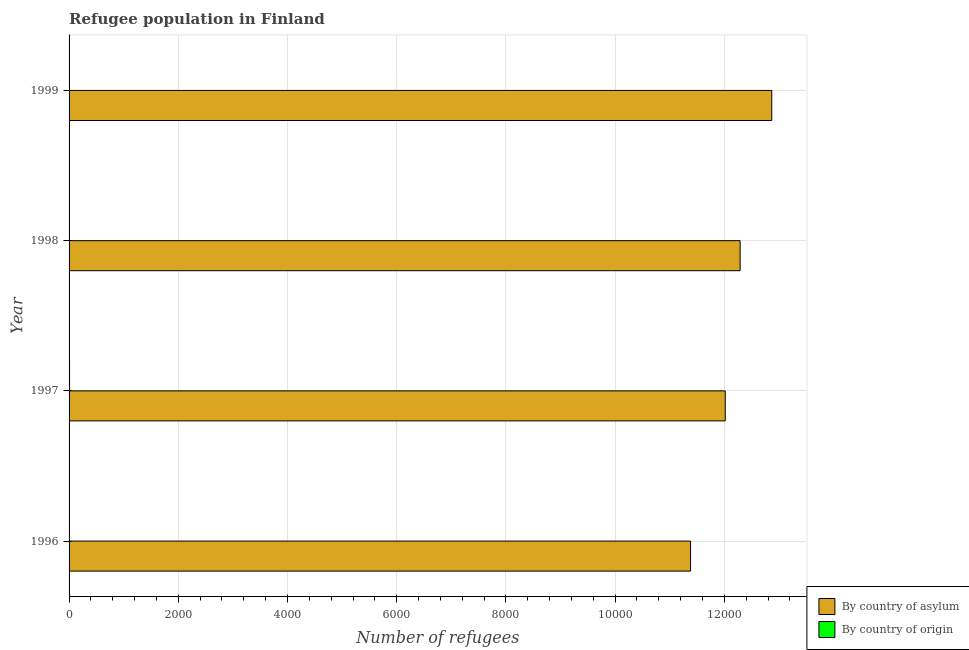Are the number of bars on each tick of the Y-axis equal?
Offer a terse response. Yes. How many bars are there on the 3rd tick from the top?
Provide a short and direct response. 2. How many bars are there on the 2nd tick from the bottom?
Give a very brief answer. 2. What is the label of the 3rd group of bars from the top?
Keep it short and to the point. 1997. In how many cases, is the number of bars for a given year not equal to the number of legend labels?
Keep it short and to the point. 0. What is the number of refugees by country of asylum in 1998?
Your response must be concise. 1.23e+04. Across all years, what is the maximum number of refugees by country of origin?
Your answer should be compact. 9. Across all years, what is the minimum number of refugees by country of origin?
Your answer should be very brief. 2. In which year was the number of refugees by country of origin maximum?
Make the answer very short. 1997. What is the total number of refugees by country of asylum in the graph?
Make the answer very short. 4.86e+04. What is the difference between the number of refugees by country of asylum in 1996 and that in 1999?
Your answer should be very brief. -1487. What is the difference between the number of refugees by country of origin in 1999 and the number of refugees by country of asylum in 1996?
Your response must be concise. -1.14e+04. What is the average number of refugees by country of asylum per year?
Ensure brevity in your answer.  1.21e+04. In the year 1997, what is the difference between the number of refugees by country of asylum and number of refugees by country of origin?
Your answer should be very brief. 1.20e+04. What is the ratio of the number of refugees by country of asylum in 1998 to that in 1999?
Offer a terse response. 0.95. Is the number of refugees by country of origin in 1997 less than that in 1999?
Your answer should be very brief. No. Is the difference between the number of refugees by country of asylum in 1996 and 1999 greater than the difference between the number of refugees by country of origin in 1996 and 1999?
Make the answer very short. No. What is the difference between the highest and the second highest number of refugees by country of origin?
Give a very brief answer. 2. What is the difference between the highest and the lowest number of refugees by country of asylum?
Your answer should be very brief. 1487. In how many years, is the number of refugees by country of asylum greater than the average number of refugees by country of asylum taken over all years?
Offer a terse response. 2. Is the sum of the number of refugees by country of origin in 1996 and 1999 greater than the maximum number of refugees by country of asylum across all years?
Offer a terse response. No. What does the 2nd bar from the top in 1999 represents?
Give a very brief answer. By country of asylum. What does the 2nd bar from the bottom in 1997 represents?
Ensure brevity in your answer.  By country of origin. How many bars are there?
Your answer should be compact. 8. Are the values on the major ticks of X-axis written in scientific E-notation?
Your answer should be compact. No. Does the graph contain any zero values?
Keep it short and to the point. No. Does the graph contain grids?
Provide a succinct answer. Yes. How many legend labels are there?
Your answer should be compact. 2. How are the legend labels stacked?
Your answer should be very brief. Vertical. What is the title of the graph?
Provide a succinct answer. Refugee population in Finland. Does "Old" appear as one of the legend labels in the graph?
Your response must be concise. No. What is the label or title of the X-axis?
Your answer should be compact. Number of refugees. What is the Number of refugees in By country of asylum in 1996?
Make the answer very short. 1.14e+04. What is the Number of refugees in By country of asylum in 1997?
Give a very brief answer. 1.20e+04. What is the Number of refugees of By country of origin in 1997?
Offer a very short reply. 9. What is the Number of refugees in By country of asylum in 1998?
Your answer should be compact. 1.23e+04. What is the Number of refugees in By country of asylum in 1999?
Offer a very short reply. 1.29e+04. What is the Number of refugees in By country of origin in 1999?
Offer a very short reply. 3. Across all years, what is the maximum Number of refugees in By country of asylum?
Your answer should be very brief. 1.29e+04. Across all years, what is the maximum Number of refugees in By country of origin?
Offer a terse response. 9. Across all years, what is the minimum Number of refugees of By country of asylum?
Your answer should be compact. 1.14e+04. What is the total Number of refugees of By country of asylum in the graph?
Give a very brief answer. 4.86e+04. What is the total Number of refugees of By country of origin in the graph?
Ensure brevity in your answer.  21. What is the difference between the Number of refugees in By country of asylum in 1996 and that in 1997?
Your response must be concise. -635. What is the difference between the Number of refugees in By country of asylum in 1996 and that in 1998?
Keep it short and to the point. -908. What is the difference between the Number of refugees of By country of origin in 1996 and that in 1998?
Make the answer very short. -5. What is the difference between the Number of refugees of By country of asylum in 1996 and that in 1999?
Your answer should be compact. -1487. What is the difference between the Number of refugees of By country of origin in 1996 and that in 1999?
Offer a terse response. -1. What is the difference between the Number of refugees of By country of asylum in 1997 and that in 1998?
Offer a terse response. -273. What is the difference between the Number of refugees of By country of origin in 1997 and that in 1998?
Keep it short and to the point. 2. What is the difference between the Number of refugees of By country of asylum in 1997 and that in 1999?
Give a very brief answer. -852. What is the difference between the Number of refugees of By country of origin in 1997 and that in 1999?
Your response must be concise. 6. What is the difference between the Number of refugees in By country of asylum in 1998 and that in 1999?
Your answer should be compact. -579. What is the difference between the Number of refugees in By country of origin in 1998 and that in 1999?
Provide a succinct answer. 4. What is the difference between the Number of refugees in By country of asylum in 1996 and the Number of refugees in By country of origin in 1997?
Your response must be concise. 1.14e+04. What is the difference between the Number of refugees in By country of asylum in 1996 and the Number of refugees in By country of origin in 1998?
Offer a very short reply. 1.14e+04. What is the difference between the Number of refugees in By country of asylum in 1996 and the Number of refugees in By country of origin in 1999?
Your answer should be compact. 1.14e+04. What is the difference between the Number of refugees in By country of asylum in 1997 and the Number of refugees in By country of origin in 1998?
Offer a terse response. 1.20e+04. What is the difference between the Number of refugees in By country of asylum in 1997 and the Number of refugees in By country of origin in 1999?
Make the answer very short. 1.20e+04. What is the difference between the Number of refugees in By country of asylum in 1998 and the Number of refugees in By country of origin in 1999?
Offer a very short reply. 1.23e+04. What is the average Number of refugees in By country of asylum per year?
Offer a terse response. 1.21e+04. What is the average Number of refugees in By country of origin per year?
Your answer should be very brief. 5.25. In the year 1996, what is the difference between the Number of refugees in By country of asylum and Number of refugees in By country of origin?
Provide a short and direct response. 1.14e+04. In the year 1997, what is the difference between the Number of refugees in By country of asylum and Number of refugees in By country of origin?
Make the answer very short. 1.20e+04. In the year 1998, what is the difference between the Number of refugees in By country of asylum and Number of refugees in By country of origin?
Offer a very short reply. 1.23e+04. In the year 1999, what is the difference between the Number of refugees of By country of asylum and Number of refugees of By country of origin?
Your response must be concise. 1.29e+04. What is the ratio of the Number of refugees of By country of asylum in 1996 to that in 1997?
Provide a succinct answer. 0.95. What is the ratio of the Number of refugees of By country of origin in 1996 to that in 1997?
Your answer should be compact. 0.22. What is the ratio of the Number of refugees of By country of asylum in 1996 to that in 1998?
Your answer should be compact. 0.93. What is the ratio of the Number of refugees in By country of origin in 1996 to that in 1998?
Provide a succinct answer. 0.29. What is the ratio of the Number of refugees in By country of asylum in 1996 to that in 1999?
Your answer should be very brief. 0.88. What is the ratio of the Number of refugees of By country of origin in 1996 to that in 1999?
Keep it short and to the point. 0.67. What is the ratio of the Number of refugees in By country of asylum in 1997 to that in 1998?
Give a very brief answer. 0.98. What is the ratio of the Number of refugees of By country of asylum in 1997 to that in 1999?
Your answer should be very brief. 0.93. What is the ratio of the Number of refugees of By country of origin in 1997 to that in 1999?
Your answer should be very brief. 3. What is the ratio of the Number of refugees in By country of asylum in 1998 to that in 1999?
Offer a terse response. 0.95. What is the ratio of the Number of refugees of By country of origin in 1998 to that in 1999?
Your answer should be very brief. 2.33. What is the difference between the highest and the second highest Number of refugees of By country of asylum?
Make the answer very short. 579. What is the difference between the highest and the lowest Number of refugees of By country of asylum?
Give a very brief answer. 1487. What is the difference between the highest and the lowest Number of refugees in By country of origin?
Provide a succinct answer. 7. 